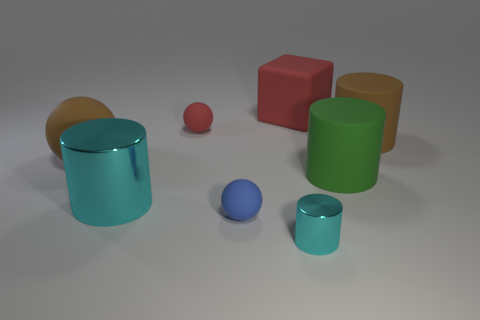Subtract 1 cylinders. How many cylinders are left? 3 Add 1 big red matte cubes. How many objects exist? 9 Subtract all blocks. How many objects are left? 7 Subtract 0 cyan cubes. How many objects are left? 8 Subtract all tiny red shiny cubes. Subtract all red objects. How many objects are left? 6 Add 8 green cylinders. How many green cylinders are left? 9 Add 8 cyan cubes. How many cyan cubes exist? 8 